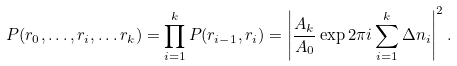<formula> <loc_0><loc_0><loc_500><loc_500>P ( r _ { 0 } , \dots , r _ { i } , \dots r _ { k } ) = \prod _ { i = 1 } ^ { k } P ( r _ { i - 1 } , r _ { i } ) = \left | \frac { A _ { k } } { A _ { 0 } } \exp 2 \pi i \sum _ { i = 1 } ^ { k } \Delta n _ { i } \right | ^ { 2 } .</formula> 